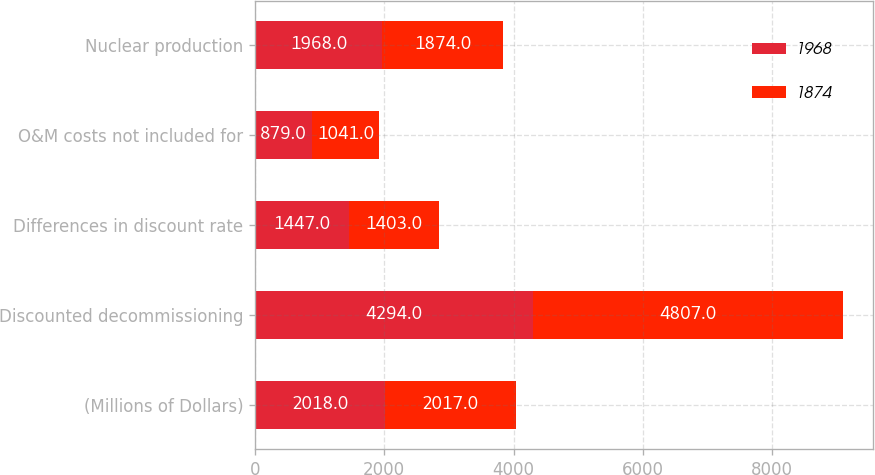Convert chart. <chart><loc_0><loc_0><loc_500><loc_500><stacked_bar_chart><ecel><fcel>(Millions of Dollars)<fcel>Discounted decommissioning<fcel>Differences in discount rate<fcel>O&M costs not included for<fcel>Nuclear production<nl><fcel>1968<fcel>2018<fcel>4294<fcel>1447<fcel>879<fcel>1968<nl><fcel>1874<fcel>2017<fcel>4807<fcel>1403<fcel>1041<fcel>1874<nl></chart> 